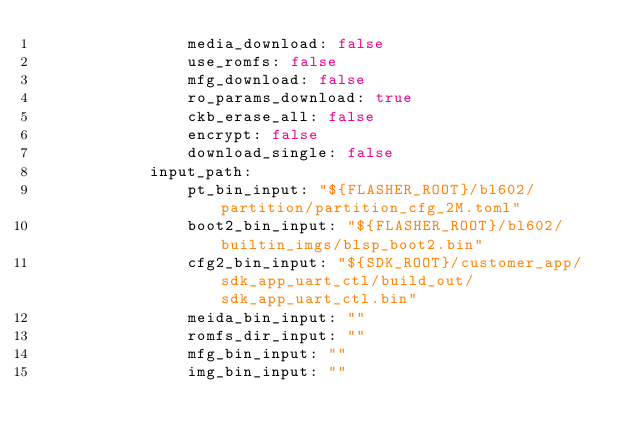Convert code to text. <code><loc_0><loc_0><loc_500><loc_500><_YAML_>                media_download: false
                use_romfs: false
                mfg_download: false
                ro_params_download: true
                ckb_erase_all: false
                encrypt: false
                download_single: false
            input_path:
                pt_bin_input: "${FLASHER_ROOT}/bl602/partition/partition_cfg_2M.toml"
                boot2_bin_input: "${FLASHER_ROOT}/bl602/builtin_imgs/blsp_boot2.bin"
                cfg2_bin_input: "${SDK_ROOT}/customer_app/sdk_app_uart_ctl/build_out/sdk_app_uart_ctl.bin"
                meida_bin_input: ""
                romfs_dir_input: ""
                mfg_bin_input: ""
                img_bin_input: ""
</code> 